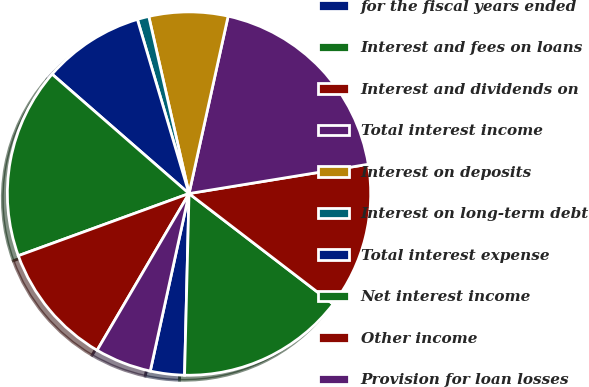<chart> <loc_0><loc_0><loc_500><loc_500><pie_chart><fcel>for the fiscal years ended<fcel>Interest and fees on loans<fcel>Interest and dividends on<fcel>Total interest income<fcel>Interest on deposits<fcel>Interest on long-term debt<fcel>Total interest expense<fcel>Net interest income<fcel>Other income<fcel>Provision for loan losses<nl><fcel>3.03%<fcel>14.98%<fcel>12.99%<fcel>18.97%<fcel>7.01%<fcel>1.03%<fcel>9.0%<fcel>16.97%<fcel>11.0%<fcel>5.02%<nl></chart> 